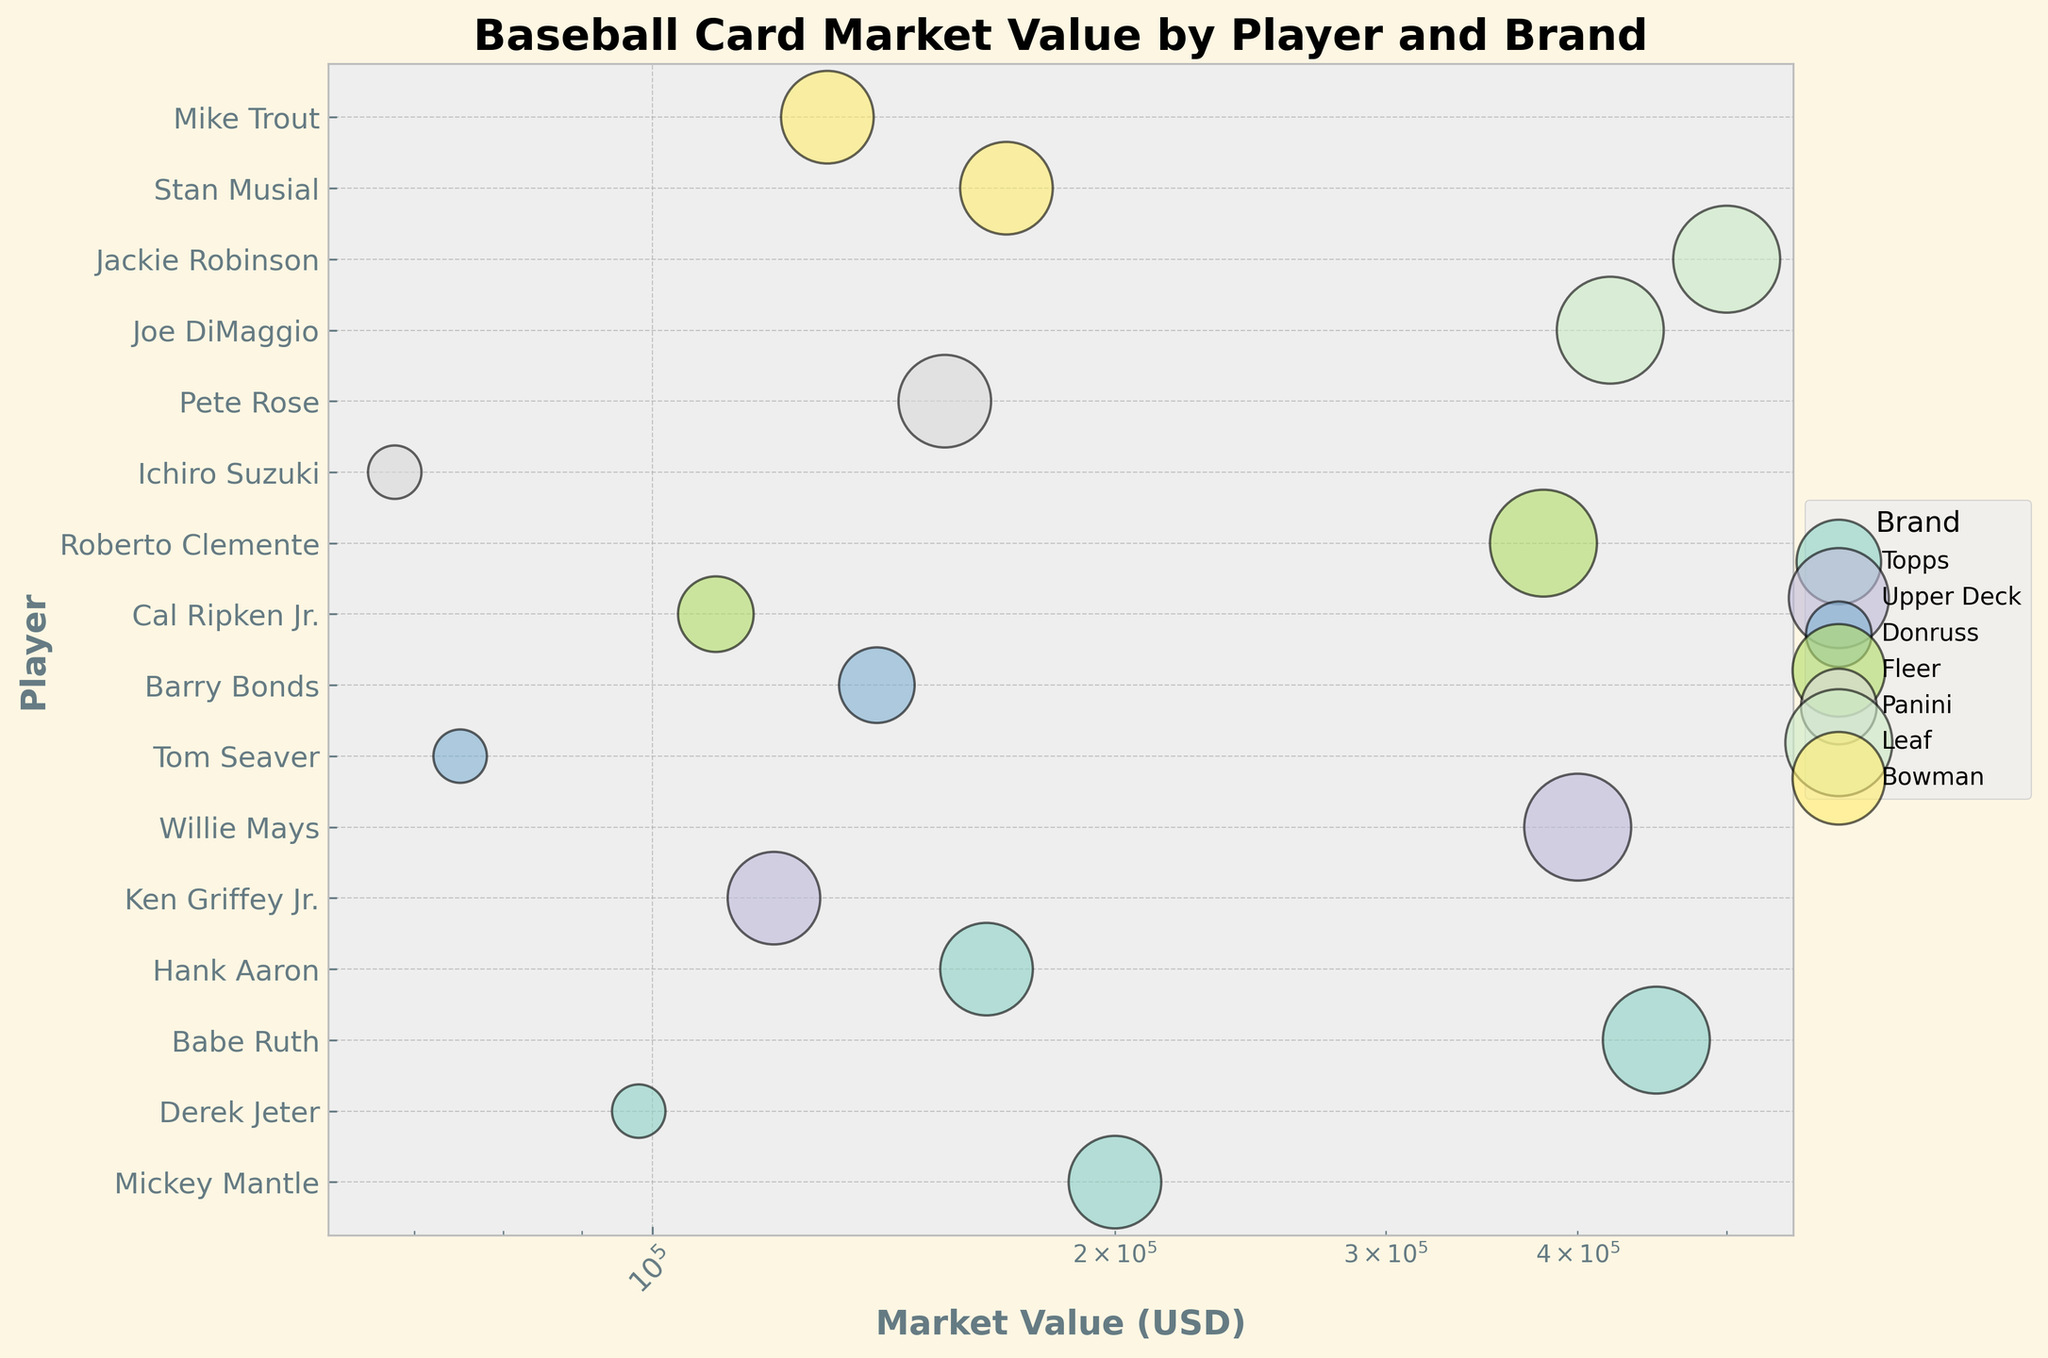Which brand has the most valuable baseball card and who's the player on it? The brand with the most valuable card is determined by finding the highest market value point on the x-axis. The highest market value is $500,000. Looking at the legend and the position of this point, the brand is Leaf, and the player is Jackie Robinson.
Answer: Leaf, Jackie Robinson What is the market value of the Topps Babe Ruth card? Find the bubble corresponding to Babe Ruth on the y-axis within the section for the brand 'Topps'. The x-axis value determines the market value.
Answer: $450,000 Which player from the Fleer brand has the highest market value? Identify the bubbles corresponding to the Fleer brand. Compare the x-axis values for these bubbles. The largest value corresponds to the player Roberto Clemente.
Answer: Roberto Clemente How does the market value of the Donruss Barry Bonds card compare to the Upper Deck Ken Griffey Jr. card? Look at the bubbles for Barry Bonds (Donruss) and Ken Griffey Jr. (Upper Deck). Compare their position on the x-axis. Barry Bonds has a market value of $140,000 while Ken Griffey Jr. has $120,000.
Answer: Barry Bonds ($140,000) is higher than Ken Griffey Jr. ($120,000) What is the historical significance category with the smallest bubble size and an example player card from that category? Bubble size corresponds to historical significance: Medium = 1x, Medium-High = 2x, High = 3x, Very High = 4x. The smallest bubbles have Medium significance, for example, Derek Jeter (Topps).
Answer: Medium significance, Derek Jeter How many players have cards valued over $200,000? Count the number of bubbles that have x-axis values greater than $200,000. There are four such bubbles.
Answer: Four players Which brand has the most diverse range of card market values? The range is calculated as the difference between the highest and lowest market value bubbles within each brand. For example, Topps: $450,000 - $98,000 = $352,000, Leaf: $500,000 - $420,000 = $80,000. Topps has the most diverse range.
Answer: Topps What is the total market value of all Upper Deck cards? Sum the market values of Upper Deck cards: Ken Griffey Jr. ($120,000) + Willie Mays ($400,000) = $520,000.
Answer: $520,000 Which brand features players with Very High historical significance and how many such cards do they have? Identify the brands of bubbles with the largest size (Very High). Topps, Upper Deck, Fleer, and Leaf are the brands with Very High significance cards. There are five such bubbles.
Answer: Topps, Upper Deck, Fleer, Leaf; five cards What is the average market value of the cards with Medium-High historical significance? Identify and sum the market values of all Medium-High historical significance cards, i.e., Barry Bonds ($140,000) and Cal Ripken Jr. ($110,000). The average is calculated as (140,000 + 110,000)/2 = $125,000.
Answer: $125,000 